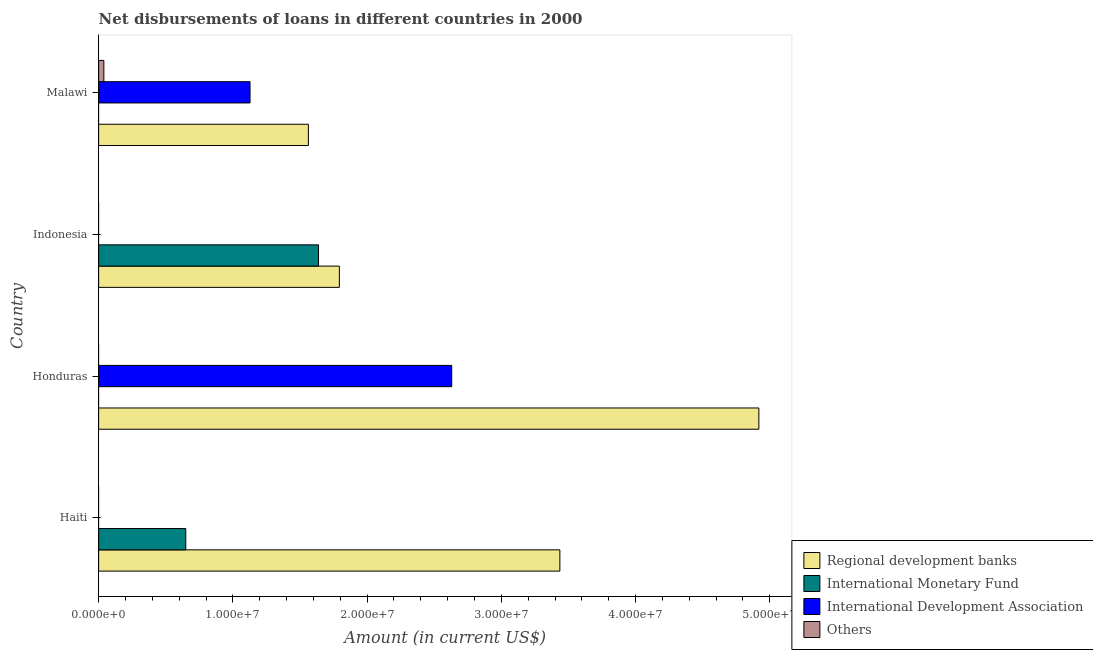How many different coloured bars are there?
Make the answer very short. 4. How many bars are there on the 3rd tick from the top?
Provide a short and direct response. 2. What is the label of the 2nd group of bars from the top?
Provide a succinct answer. Indonesia. In how many cases, is the number of bars for a given country not equal to the number of legend labels?
Make the answer very short. 4. What is the amount of loan disimbursed by regional development banks in Indonesia?
Provide a short and direct response. 1.79e+07. Across all countries, what is the maximum amount of loan disimbursed by regional development banks?
Make the answer very short. 4.92e+07. In which country was the amount of loan disimbursed by regional development banks maximum?
Offer a terse response. Honduras. What is the total amount of loan disimbursed by international development association in the graph?
Your response must be concise. 3.76e+07. What is the difference between the amount of loan disimbursed by regional development banks in Haiti and that in Honduras?
Give a very brief answer. -1.48e+07. What is the difference between the amount of loan disimbursed by regional development banks in Honduras and the amount of loan disimbursed by international monetary fund in Indonesia?
Your answer should be compact. 3.28e+07. What is the average amount of loan disimbursed by other organisations per country?
Provide a short and direct response. 9.72e+04. What is the difference between the amount of loan disimbursed by regional development banks and amount of loan disimbursed by international monetary fund in Indonesia?
Ensure brevity in your answer.  1.55e+06. In how many countries, is the amount of loan disimbursed by regional development banks greater than 16000000 US$?
Ensure brevity in your answer.  3. What is the ratio of the amount of loan disimbursed by regional development banks in Haiti to that in Malawi?
Ensure brevity in your answer.  2.2. What is the difference between the highest and the second highest amount of loan disimbursed by regional development banks?
Your answer should be very brief. 1.48e+07. What is the difference between the highest and the lowest amount of loan disimbursed by regional development banks?
Give a very brief answer. 3.36e+07. Is it the case that in every country, the sum of the amount of loan disimbursed by international development association and amount of loan disimbursed by international monetary fund is greater than the sum of amount of loan disimbursed by other organisations and amount of loan disimbursed by regional development banks?
Ensure brevity in your answer.  No. How many bars are there?
Provide a succinct answer. 9. How many countries are there in the graph?
Offer a terse response. 4. What is the difference between two consecutive major ticks on the X-axis?
Your response must be concise. 1.00e+07. Does the graph contain any zero values?
Your answer should be very brief. Yes. Does the graph contain grids?
Your response must be concise. No. What is the title of the graph?
Your answer should be very brief. Net disbursements of loans in different countries in 2000. What is the label or title of the X-axis?
Keep it short and to the point. Amount (in current US$). What is the label or title of the Y-axis?
Your answer should be very brief. Country. What is the Amount (in current US$) in Regional development banks in Haiti?
Provide a short and direct response. 3.44e+07. What is the Amount (in current US$) of International Monetary Fund in Haiti?
Provide a short and direct response. 6.49e+06. What is the Amount (in current US$) in Regional development banks in Honduras?
Your answer should be compact. 4.92e+07. What is the Amount (in current US$) in International Monetary Fund in Honduras?
Your answer should be compact. 0. What is the Amount (in current US$) in International Development Association in Honduras?
Ensure brevity in your answer.  2.63e+07. What is the Amount (in current US$) of Others in Honduras?
Offer a terse response. 0. What is the Amount (in current US$) in Regional development banks in Indonesia?
Provide a short and direct response. 1.79e+07. What is the Amount (in current US$) of International Monetary Fund in Indonesia?
Ensure brevity in your answer.  1.64e+07. What is the Amount (in current US$) in International Development Association in Indonesia?
Make the answer very short. 0. What is the Amount (in current US$) of Regional development banks in Malawi?
Offer a very short reply. 1.56e+07. What is the Amount (in current US$) of International Monetary Fund in Malawi?
Provide a short and direct response. 0. What is the Amount (in current US$) in International Development Association in Malawi?
Provide a succinct answer. 1.13e+07. What is the Amount (in current US$) in Others in Malawi?
Ensure brevity in your answer.  3.89e+05. Across all countries, what is the maximum Amount (in current US$) in Regional development banks?
Offer a terse response. 4.92e+07. Across all countries, what is the maximum Amount (in current US$) of International Monetary Fund?
Provide a short and direct response. 1.64e+07. Across all countries, what is the maximum Amount (in current US$) in International Development Association?
Ensure brevity in your answer.  2.63e+07. Across all countries, what is the maximum Amount (in current US$) in Others?
Keep it short and to the point. 3.89e+05. Across all countries, what is the minimum Amount (in current US$) of Regional development banks?
Ensure brevity in your answer.  1.56e+07. Across all countries, what is the minimum Amount (in current US$) of International Development Association?
Offer a very short reply. 0. Across all countries, what is the minimum Amount (in current US$) of Others?
Offer a terse response. 0. What is the total Amount (in current US$) in Regional development banks in the graph?
Ensure brevity in your answer.  1.17e+08. What is the total Amount (in current US$) in International Monetary Fund in the graph?
Your answer should be very brief. 2.29e+07. What is the total Amount (in current US$) in International Development Association in the graph?
Provide a succinct answer. 3.76e+07. What is the total Amount (in current US$) of Others in the graph?
Your answer should be very brief. 3.89e+05. What is the difference between the Amount (in current US$) in Regional development banks in Haiti and that in Honduras?
Make the answer very short. -1.48e+07. What is the difference between the Amount (in current US$) of Regional development banks in Haiti and that in Indonesia?
Ensure brevity in your answer.  1.64e+07. What is the difference between the Amount (in current US$) in International Monetary Fund in Haiti and that in Indonesia?
Offer a very short reply. -9.89e+06. What is the difference between the Amount (in current US$) in Regional development banks in Haiti and that in Malawi?
Ensure brevity in your answer.  1.87e+07. What is the difference between the Amount (in current US$) of Regional development banks in Honduras and that in Indonesia?
Make the answer very short. 3.13e+07. What is the difference between the Amount (in current US$) in Regional development banks in Honduras and that in Malawi?
Give a very brief answer. 3.36e+07. What is the difference between the Amount (in current US$) of International Development Association in Honduras and that in Malawi?
Your answer should be compact. 1.50e+07. What is the difference between the Amount (in current US$) in Regional development banks in Indonesia and that in Malawi?
Offer a terse response. 2.31e+06. What is the difference between the Amount (in current US$) in Regional development banks in Haiti and the Amount (in current US$) in International Development Association in Honduras?
Your response must be concise. 8.06e+06. What is the difference between the Amount (in current US$) in International Monetary Fund in Haiti and the Amount (in current US$) in International Development Association in Honduras?
Give a very brief answer. -1.98e+07. What is the difference between the Amount (in current US$) of Regional development banks in Haiti and the Amount (in current US$) of International Monetary Fund in Indonesia?
Offer a terse response. 1.80e+07. What is the difference between the Amount (in current US$) in Regional development banks in Haiti and the Amount (in current US$) in International Development Association in Malawi?
Your answer should be compact. 2.31e+07. What is the difference between the Amount (in current US$) in Regional development banks in Haiti and the Amount (in current US$) in Others in Malawi?
Keep it short and to the point. 3.40e+07. What is the difference between the Amount (in current US$) in International Monetary Fund in Haiti and the Amount (in current US$) in International Development Association in Malawi?
Keep it short and to the point. -4.79e+06. What is the difference between the Amount (in current US$) of International Monetary Fund in Haiti and the Amount (in current US$) of Others in Malawi?
Offer a very short reply. 6.10e+06. What is the difference between the Amount (in current US$) in Regional development banks in Honduras and the Amount (in current US$) in International Monetary Fund in Indonesia?
Keep it short and to the point. 3.28e+07. What is the difference between the Amount (in current US$) of Regional development banks in Honduras and the Amount (in current US$) of International Development Association in Malawi?
Your answer should be compact. 3.79e+07. What is the difference between the Amount (in current US$) in Regional development banks in Honduras and the Amount (in current US$) in Others in Malawi?
Offer a very short reply. 4.88e+07. What is the difference between the Amount (in current US$) of International Development Association in Honduras and the Amount (in current US$) of Others in Malawi?
Keep it short and to the point. 2.59e+07. What is the difference between the Amount (in current US$) in Regional development banks in Indonesia and the Amount (in current US$) in International Development Association in Malawi?
Provide a short and direct response. 6.66e+06. What is the difference between the Amount (in current US$) in Regional development banks in Indonesia and the Amount (in current US$) in Others in Malawi?
Provide a succinct answer. 1.75e+07. What is the difference between the Amount (in current US$) in International Monetary Fund in Indonesia and the Amount (in current US$) in International Development Association in Malawi?
Your response must be concise. 5.10e+06. What is the difference between the Amount (in current US$) in International Monetary Fund in Indonesia and the Amount (in current US$) in Others in Malawi?
Provide a succinct answer. 1.60e+07. What is the average Amount (in current US$) of Regional development banks per country?
Ensure brevity in your answer.  2.93e+07. What is the average Amount (in current US$) of International Monetary Fund per country?
Make the answer very short. 5.72e+06. What is the average Amount (in current US$) of International Development Association per country?
Offer a very short reply. 9.40e+06. What is the average Amount (in current US$) of Others per country?
Your response must be concise. 9.72e+04. What is the difference between the Amount (in current US$) in Regional development banks and Amount (in current US$) in International Monetary Fund in Haiti?
Your answer should be very brief. 2.79e+07. What is the difference between the Amount (in current US$) of Regional development banks and Amount (in current US$) of International Development Association in Honduras?
Offer a terse response. 2.29e+07. What is the difference between the Amount (in current US$) of Regional development banks and Amount (in current US$) of International Monetary Fund in Indonesia?
Offer a terse response. 1.55e+06. What is the difference between the Amount (in current US$) in Regional development banks and Amount (in current US$) in International Development Association in Malawi?
Your response must be concise. 4.35e+06. What is the difference between the Amount (in current US$) of Regional development banks and Amount (in current US$) of Others in Malawi?
Provide a succinct answer. 1.52e+07. What is the difference between the Amount (in current US$) of International Development Association and Amount (in current US$) of Others in Malawi?
Offer a very short reply. 1.09e+07. What is the ratio of the Amount (in current US$) in Regional development banks in Haiti to that in Honduras?
Keep it short and to the point. 0.7. What is the ratio of the Amount (in current US$) in Regional development banks in Haiti to that in Indonesia?
Provide a succinct answer. 1.92. What is the ratio of the Amount (in current US$) of International Monetary Fund in Haiti to that in Indonesia?
Make the answer very short. 0.4. What is the ratio of the Amount (in current US$) in Regional development banks in Haiti to that in Malawi?
Your response must be concise. 2.2. What is the ratio of the Amount (in current US$) in Regional development banks in Honduras to that in Indonesia?
Your answer should be very brief. 2.74. What is the ratio of the Amount (in current US$) of Regional development banks in Honduras to that in Malawi?
Give a very brief answer. 3.15. What is the ratio of the Amount (in current US$) of International Development Association in Honduras to that in Malawi?
Keep it short and to the point. 2.33. What is the ratio of the Amount (in current US$) of Regional development banks in Indonesia to that in Malawi?
Make the answer very short. 1.15. What is the difference between the highest and the second highest Amount (in current US$) in Regional development banks?
Ensure brevity in your answer.  1.48e+07. What is the difference between the highest and the lowest Amount (in current US$) in Regional development banks?
Make the answer very short. 3.36e+07. What is the difference between the highest and the lowest Amount (in current US$) of International Monetary Fund?
Make the answer very short. 1.64e+07. What is the difference between the highest and the lowest Amount (in current US$) of International Development Association?
Make the answer very short. 2.63e+07. What is the difference between the highest and the lowest Amount (in current US$) of Others?
Your response must be concise. 3.89e+05. 